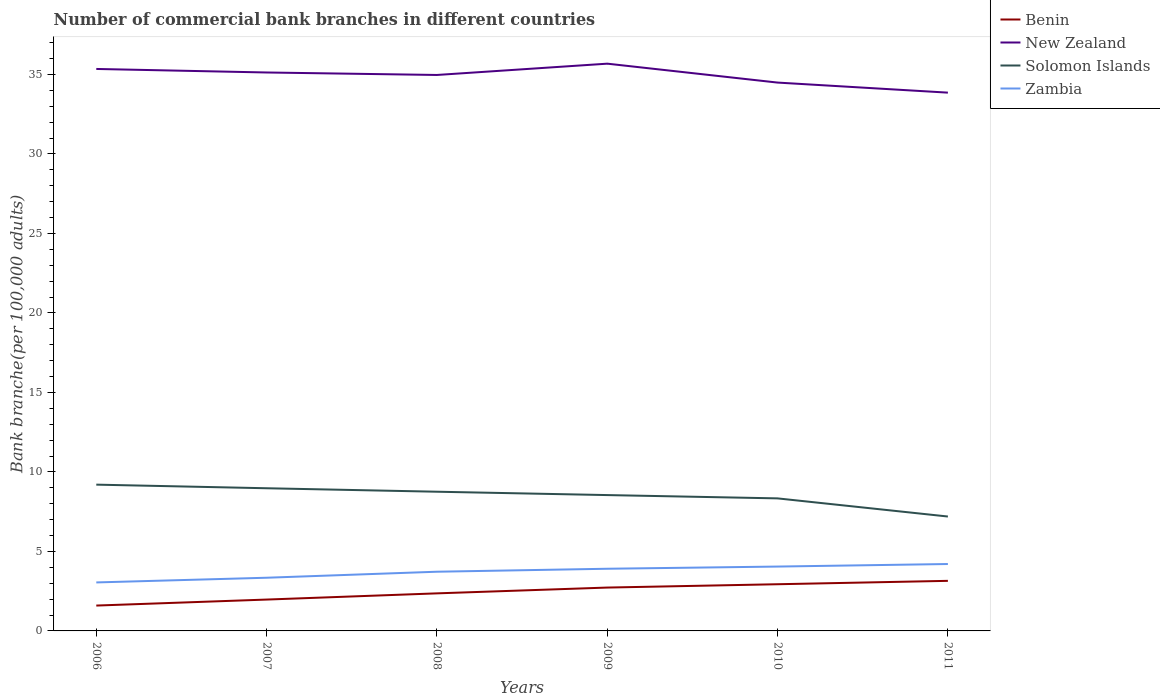Does the line corresponding to Zambia intersect with the line corresponding to New Zealand?
Offer a terse response. No. Across all years, what is the maximum number of commercial bank branches in New Zealand?
Offer a terse response. 33.85. In which year was the number of commercial bank branches in New Zealand maximum?
Keep it short and to the point. 2011. What is the total number of commercial bank branches in Zambia in the graph?
Offer a very short reply. -0.16. What is the difference between the highest and the second highest number of commercial bank branches in Benin?
Keep it short and to the point. 1.55. How many lines are there?
Your answer should be compact. 4. How many years are there in the graph?
Make the answer very short. 6. What is the difference between two consecutive major ticks on the Y-axis?
Provide a short and direct response. 5. Are the values on the major ticks of Y-axis written in scientific E-notation?
Keep it short and to the point. No. Does the graph contain any zero values?
Your answer should be very brief. No. Does the graph contain grids?
Give a very brief answer. No. How many legend labels are there?
Offer a terse response. 4. How are the legend labels stacked?
Provide a succinct answer. Vertical. What is the title of the graph?
Provide a short and direct response. Number of commercial bank branches in different countries. Does "Jamaica" appear as one of the legend labels in the graph?
Offer a very short reply. No. What is the label or title of the Y-axis?
Offer a very short reply. Bank branche(per 100,0 adults). What is the Bank branche(per 100,000 adults) of Benin in 2006?
Give a very brief answer. 1.59. What is the Bank branche(per 100,000 adults) of New Zealand in 2006?
Offer a very short reply. 35.34. What is the Bank branche(per 100,000 adults) in Solomon Islands in 2006?
Ensure brevity in your answer.  9.2. What is the Bank branche(per 100,000 adults) in Zambia in 2006?
Provide a succinct answer. 3.05. What is the Bank branche(per 100,000 adults) of Benin in 2007?
Offer a terse response. 1.97. What is the Bank branche(per 100,000 adults) of New Zealand in 2007?
Your response must be concise. 35.12. What is the Bank branche(per 100,000 adults) in Solomon Islands in 2007?
Make the answer very short. 8.97. What is the Bank branche(per 100,000 adults) of Zambia in 2007?
Provide a succinct answer. 3.34. What is the Bank branche(per 100,000 adults) of Benin in 2008?
Make the answer very short. 2.36. What is the Bank branche(per 100,000 adults) of New Zealand in 2008?
Your answer should be compact. 34.97. What is the Bank branche(per 100,000 adults) in Solomon Islands in 2008?
Keep it short and to the point. 8.75. What is the Bank branche(per 100,000 adults) of Zambia in 2008?
Offer a terse response. 3.72. What is the Bank branche(per 100,000 adults) of Benin in 2009?
Provide a succinct answer. 2.73. What is the Bank branche(per 100,000 adults) in New Zealand in 2009?
Your response must be concise. 35.68. What is the Bank branche(per 100,000 adults) in Solomon Islands in 2009?
Offer a terse response. 8.54. What is the Bank branche(per 100,000 adults) of Zambia in 2009?
Make the answer very short. 3.91. What is the Bank branche(per 100,000 adults) in Benin in 2010?
Offer a terse response. 2.94. What is the Bank branche(per 100,000 adults) of New Zealand in 2010?
Offer a terse response. 34.49. What is the Bank branche(per 100,000 adults) of Solomon Islands in 2010?
Ensure brevity in your answer.  8.34. What is the Bank branche(per 100,000 adults) in Zambia in 2010?
Your answer should be compact. 4.05. What is the Bank branche(per 100,000 adults) of Benin in 2011?
Keep it short and to the point. 3.15. What is the Bank branche(per 100,000 adults) in New Zealand in 2011?
Offer a terse response. 33.85. What is the Bank branche(per 100,000 adults) of Solomon Islands in 2011?
Keep it short and to the point. 7.19. What is the Bank branche(per 100,000 adults) in Zambia in 2011?
Ensure brevity in your answer.  4.21. Across all years, what is the maximum Bank branche(per 100,000 adults) in Benin?
Make the answer very short. 3.15. Across all years, what is the maximum Bank branche(per 100,000 adults) in New Zealand?
Your answer should be compact. 35.68. Across all years, what is the maximum Bank branche(per 100,000 adults) in Solomon Islands?
Offer a very short reply. 9.2. Across all years, what is the maximum Bank branche(per 100,000 adults) of Zambia?
Provide a succinct answer. 4.21. Across all years, what is the minimum Bank branche(per 100,000 adults) in Benin?
Your response must be concise. 1.59. Across all years, what is the minimum Bank branche(per 100,000 adults) of New Zealand?
Provide a short and direct response. 33.85. Across all years, what is the minimum Bank branche(per 100,000 adults) in Solomon Islands?
Provide a succinct answer. 7.19. Across all years, what is the minimum Bank branche(per 100,000 adults) in Zambia?
Offer a very short reply. 3.05. What is the total Bank branche(per 100,000 adults) in Benin in the graph?
Provide a short and direct response. 14.74. What is the total Bank branche(per 100,000 adults) of New Zealand in the graph?
Provide a short and direct response. 209.45. What is the total Bank branche(per 100,000 adults) of Solomon Islands in the graph?
Your answer should be very brief. 51. What is the total Bank branche(per 100,000 adults) of Zambia in the graph?
Ensure brevity in your answer.  22.28. What is the difference between the Bank branche(per 100,000 adults) of Benin in 2006 and that in 2007?
Provide a short and direct response. -0.38. What is the difference between the Bank branche(per 100,000 adults) of New Zealand in 2006 and that in 2007?
Give a very brief answer. 0.22. What is the difference between the Bank branche(per 100,000 adults) of Solomon Islands in 2006 and that in 2007?
Your response must be concise. 0.23. What is the difference between the Bank branche(per 100,000 adults) in Zambia in 2006 and that in 2007?
Your response must be concise. -0.3. What is the difference between the Bank branche(per 100,000 adults) of Benin in 2006 and that in 2008?
Your response must be concise. -0.77. What is the difference between the Bank branche(per 100,000 adults) of New Zealand in 2006 and that in 2008?
Offer a very short reply. 0.38. What is the difference between the Bank branche(per 100,000 adults) in Solomon Islands in 2006 and that in 2008?
Your answer should be very brief. 0.45. What is the difference between the Bank branche(per 100,000 adults) of Zambia in 2006 and that in 2008?
Offer a terse response. -0.67. What is the difference between the Bank branche(per 100,000 adults) of Benin in 2006 and that in 2009?
Your response must be concise. -1.13. What is the difference between the Bank branche(per 100,000 adults) in New Zealand in 2006 and that in 2009?
Provide a short and direct response. -0.33. What is the difference between the Bank branche(per 100,000 adults) in Solomon Islands in 2006 and that in 2009?
Make the answer very short. 0.66. What is the difference between the Bank branche(per 100,000 adults) of Zambia in 2006 and that in 2009?
Give a very brief answer. -0.86. What is the difference between the Bank branche(per 100,000 adults) of Benin in 2006 and that in 2010?
Your answer should be compact. -1.34. What is the difference between the Bank branche(per 100,000 adults) in New Zealand in 2006 and that in 2010?
Your answer should be compact. 0.86. What is the difference between the Bank branche(per 100,000 adults) in Solomon Islands in 2006 and that in 2010?
Provide a succinct answer. 0.86. What is the difference between the Bank branche(per 100,000 adults) of Zambia in 2006 and that in 2010?
Provide a succinct answer. -1. What is the difference between the Bank branche(per 100,000 adults) of Benin in 2006 and that in 2011?
Give a very brief answer. -1.55. What is the difference between the Bank branche(per 100,000 adults) of New Zealand in 2006 and that in 2011?
Offer a very short reply. 1.49. What is the difference between the Bank branche(per 100,000 adults) of Solomon Islands in 2006 and that in 2011?
Provide a succinct answer. 2.01. What is the difference between the Bank branche(per 100,000 adults) of Zambia in 2006 and that in 2011?
Ensure brevity in your answer.  -1.16. What is the difference between the Bank branche(per 100,000 adults) in Benin in 2007 and that in 2008?
Provide a succinct answer. -0.39. What is the difference between the Bank branche(per 100,000 adults) in New Zealand in 2007 and that in 2008?
Offer a very short reply. 0.16. What is the difference between the Bank branche(per 100,000 adults) in Solomon Islands in 2007 and that in 2008?
Your answer should be compact. 0.22. What is the difference between the Bank branche(per 100,000 adults) of Zambia in 2007 and that in 2008?
Your response must be concise. -0.38. What is the difference between the Bank branche(per 100,000 adults) in Benin in 2007 and that in 2009?
Keep it short and to the point. -0.76. What is the difference between the Bank branche(per 100,000 adults) of New Zealand in 2007 and that in 2009?
Keep it short and to the point. -0.55. What is the difference between the Bank branche(per 100,000 adults) in Solomon Islands in 2007 and that in 2009?
Provide a short and direct response. 0.43. What is the difference between the Bank branche(per 100,000 adults) of Zambia in 2007 and that in 2009?
Give a very brief answer. -0.56. What is the difference between the Bank branche(per 100,000 adults) in Benin in 2007 and that in 2010?
Your answer should be compact. -0.96. What is the difference between the Bank branche(per 100,000 adults) in New Zealand in 2007 and that in 2010?
Your answer should be compact. 0.63. What is the difference between the Bank branche(per 100,000 adults) of Solomon Islands in 2007 and that in 2010?
Your answer should be very brief. 0.64. What is the difference between the Bank branche(per 100,000 adults) of Zambia in 2007 and that in 2010?
Make the answer very short. -0.7. What is the difference between the Bank branche(per 100,000 adults) in Benin in 2007 and that in 2011?
Make the answer very short. -1.18. What is the difference between the Bank branche(per 100,000 adults) in New Zealand in 2007 and that in 2011?
Offer a very short reply. 1.27. What is the difference between the Bank branche(per 100,000 adults) in Solomon Islands in 2007 and that in 2011?
Keep it short and to the point. 1.78. What is the difference between the Bank branche(per 100,000 adults) in Zambia in 2007 and that in 2011?
Make the answer very short. -0.86. What is the difference between the Bank branche(per 100,000 adults) in Benin in 2008 and that in 2009?
Provide a short and direct response. -0.36. What is the difference between the Bank branche(per 100,000 adults) of New Zealand in 2008 and that in 2009?
Your answer should be compact. -0.71. What is the difference between the Bank branche(per 100,000 adults) in Solomon Islands in 2008 and that in 2009?
Your response must be concise. 0.21. What is the difference between the Bank branche(per 100,000 adults) of Zambia in 2008 and that in 2009?
Keep it short and to the point. -0.19. What is the difference between the Bank branche(per 100,000 adults) in Benin in 2008 and that in 2010?
Your answer should be compact. -0.57. What is the difference between the Bank branche(per 100,000 adults) in New Zealand in 2008 and that in 2010?
Your answer should be compact. 0.48. What is the difference between the Bank branche(per 100,000 adults) of Solomon Islands in 2008 and that in 2010?
Give a very brief answer. 0.42. What is the difference between the Bank branche(per 100,000 adults) in Zambia in 2008 and that in 2010?
Make the answer very short. -0.32. What is the difference between the Bank branche(per 100,000 adults) of Benin in 2008 and that in 2011?
Provide a succinct answer. -0.79. What is the difference between the Bank branche(per 100,000 adults) of New Zealand in 2008 and that in 2011?
Give a very brief answer. 1.11. What is the difference between the Bank branche(per 100,000 adults) in Solomon Islands in 2008 and that in 2011?
Your answer should be very brief. 1.56. What is the difference between the Bank branche(per 100,000 adults) in Zambia in 2008 and that in 2011?
Your answer should be compact. -0.48. What is the difference between the Bank branche(per 100,000 adults) in Benin in 2009 and that in 2010?
Your answer should be very brief. -0.21. What is the difference between the Bank branche(per 100,000 adults) in New Zealand in 2009 and that in 2010?
Provide a succinct answer. 1.19. What is the difference between the Bank branche(per 100,000 adults) of Solomon Islands in 2009 and that in 2010?
Provide a short and direct response. 0.21. What is the difference between the Bank branche(per 100,000 adults) of Zambia in 2009 and that in 2010?
Offer a very short reply. -0.14. What is the difference between the Bank branche(per 100,000 adults) of Benin in 2009 and that in 2011?
Offer a very short reply. -0.42. What is the difference between the Bank branche(per 100,000 adults) in New Zealand in 2009 and that in 2011?
Keep it short and to the point. 1.82. What is the difference between the Bank branche(per 100,000 adults) of Solomon Islands in 2009 and that in 2011?
Your answer should be compact. 1.35. What is the difference between the Bank branche(per 100,000 adults) in Zambia in 2009 and that in 2011?
Your answer should be compact. -0.3. What is the difference between the Bank branche(per 100,000 adults) of Benin in 2010 and that in 2011?
Your response must be concise. -0.21. What is the difference between the Bank branche(per 100,000 adults) of New Zealand in 2010 and that in 2011?
Provide a succinct answer. 0.63. What is the difference between the Bank branche(per 100,000 adults) of Solomon Islands in 2010 and that in 2011?
Give a very brief answer. 1.14. What is the difference between the Bank branche(per 100,000 adults) of Zambia in 2010 and that in 2011?
Offer a terse response. -0.16. What is the difference between the Bank branche(per 100,000 adults) in Benin in 2006 and the Bank branche(per 100,000 adults) in New Zealand in 2007?
Provide a short and direct response. -33.53. What is the difference between the Bank branche(per 100,000 adults) in Benin in 2006 and the Bank branche(per 100,000 adults) in Solomon Islands in 2007?
Ensure brevity in your answer.  -7.38. What is the difference between the Bank branche(per 100,000 adults) in Benin in 2006 and the Bank branche(per 100,000 adults) in Zambia in 2007?
Provide a succinct answer. -1.75. What is the difference between the Bank branche(per 100,000 adults) of New Zealand in 2006 and the Bank branche(per 100,000 adults) of Solomon Islands in 2007?
Keep it short and to the point. 26.37. What is the difference between the Bank branche(per 100,000 adults) in New Zealand in 2006 and the Bank branche(per 100,000 adults) in Zambia in 2007?
Offer a very short reply. 32. What is the difference between the Bank branche(per 100,000 adults) of Solomon Islands in 2006 and the Bank branche(per 100,000 adults) of Zambia in 2007?
Provide a succinct answer. 5.86. What is the difference between the Bank branche(per 100,000 adults) in Benin in 2006 and the Bank branche(per 100,000 adults) in New Zealand in 2008?
Provide a short and direct response. -33.37. What is the difference between the Bank branche(per 100,000 adults) in Benin in 2006 and the Bank branche(per 100,000 adults) in Solomon Islands in 2008?
Provide a succinct answer. -7.16. What is the difference between the Bank branche(per 100,000 adults) in Benin in 2006 and the Bank branche(per 100,000 adults) in Zambia in 2008?
Your answer should be compact. -2.13. What is the difference between the Bank branche(per 100,000 adults) of New Zealand in 2006 and the Bank branche(per 100,000 adults) of Solomon Islands in 2008?
Give a very brief answer. 26.59. What is the difference between the Bank branche(per 100,000 adults) in New Zealand in 2006 and the Bank branche(per 100,000 adults) in Zambia in 2008?
Ensure brevity in your answer.  31.62. What is the difference between the Bank branche(per 100,000 adults) of Solomon Islands in 2006 and the Bank branche(per 100,000 adults) of Zambia in 2008?
Your answer should be very brief. 5.48. What is the difference between the Bank branche(per 100,000 adults) in Benin in 2006 and the Bank branche(per 100,000 adults) in New Zealand in 2009?
Ensure brevity in your answer.  -34.08. What is the difference between the Bank branche(per 100,000 adults) of Benin in 2006 and the Bank branche(per 100,000 adults) of Solomon Islands in 2009?
Your answer should be very brief. -6.95. What is the difference between the Bank branche(per 100,000 adults) of Benin in 2006 and the Bank branche(per 100,000 adults) of Zambia in 2009?
Your answer should be compact. -2.31. What is the difference between the Bank branche(per 100,000 adults) of New Zealand in 2006 and the Bank branche(per 100,000 adults) of Solomon Islands in 2009?
Ensure brevity in your answer.  26.8. What is the difference between the Bank branche(per 100,000 adults) in New Zealand in 2006 and the Bank branche(per 100,000 adults) in Zambia in 2009?
Make the answer very short. 31.43. What is the difference between the Bank branche(per 100,000 adults) in Solomon Islands in 2006 and the Bank branche(per 100,000 adults) in Zambia in 2009?
Ensure brevity in your answer.  5.29. What is the difference between the Bank branche(per 100,000 adults) of Benin in 2006 and the Bank branche(per 100,000 adults) of New Zealand in 2010?
Provide a succinct answer. -32.89. What is the difference between the Bank branche(per 100,000 adults) of Benin in 2006 and the Bank branche(per 100,000 adults) of Solomon Islands in 2010?
Give a very brief answer. -6.74. What is the difference between the Bank branche(per 100,000 adults) in Benin in 2006 and the Bank branche(per 100,000 adults) in Zambia in 2010?
Make the answer very short. -2.45. What is the difference between the Bank branche(per 100,000 adults) of New Zealand in 2006 and the Bank branche(per 100,000 adults) of Solomon Islands in 2010?
Give a very brief answer. 27.01. What is the difference between the Bank branche(per 100,000 adults) in New Zealand in 2006 and the Bank branche(per 100,000 adults) in Zambia in 2010?
Your answer should be very brief. 31.3. What is the difference between the Bank branche(per 100,000 adults) in Solomon Islands in 2006 and the Bank branche(per 100,000 adults) in Zambia in 2010?
Your answer should be very brief. 5.15. What is the difference between the Bank branche(per 100,000 adults) in Benin in 2006 and the Bank branche(per 100,000 adults) in New Zealand in 2011?
Your answer should be compact. -32.26. What is the difference between the Bank branche(per 100,000 adults) in Benin in 2006 and the Bank branche(per 100,000 adults) in Solomon Islands in 2011?
Offer a very short reply. -5.6. What is the difference between the Bank branche(per 100,000 adults) of Benin in 2006 and the Bank branche(per 100,000 adults) of Zambia in 2011?
Give a very brief answer. -2.61. What is the difference between the Bank branche(per 100,000 adults) in New Zealand in 2006 and the Bank branche(per 100,000 adults) in Solomon Islands in 2011?
Your answer should be compact. 28.15. What is the difference between the Bank branche(per 100,000 adults) of New Zealand in 2006 and the Bank branche(per 100,000 adults) of Zambia in 2011?
Offer a very short reply. 31.14. What is the difference between the Bank branche(per 100,000 adults) of Solomon Islands in 2006 and the Bank branche(per 100,000 adults) of Zambia in 2011?
Give a very brief answer. 4.99. What is the difference between the Bank branche(per 100,000 adults) of Benin in 2007 and the Bank branche(per 100,000 adults) of New Zealand in 2008?
Offer a very short reply. -32.99. What is the difference between the Bank branche(per 100,000 adults) of Benin in 2007 and the Bank branche(per 100,000 adults) of Solomon Islands in 2008?
Ensure brevity in your answer.  -6.78. What is the difference between the Bank branche(per 100,000 adults) in Benin in 2007 and the Bank branche(per 100,000 adults) in Zambia in 2008?
Provide a short and direct response. -1.75. What is the difference between the Bank branche(per 100,000 adults) in New Zealand in 2007 and the Bank branche(per 100,000 adults) in Solomon Islands in 2008?
Give a very brief answer. 26.37. What is the difference between the Bank branche(per 100,000 adults) in New Zealand in 2007 and the Bank branche(per 100,000 adults) in Zambia in 2008?
Make the answer very short. 31.4. What is the difference between the Bank branche(per 100,000 adults) of Solomon Islands in 2007 and the Bank branche(per 100,000 adults) of Zambia in 2008?
Offer a terse response. 5.25. What is the difference between the Bank branche(per 100,000 adults) in Benin in 2007 and the Bank branche(per 100,000 adults) in New Zealand in 2009?
Your answer should be very brief. -33.7. What is the difference between the Bank branche(per 100,000 adults) in Benin in 2007 and the Bank branche(per 100,000 adults) in Solomon Islands in 2009?
Give a very brief answer. -6.57. What is the difference between the Bank branche(per 100,000 adults) of Benin in 2007 and the Bank branche(per 100,000 adults) of Zambia in 2009?
Provide a succinct answer. -1.94. What is the difference between the Bank branche(per 100,000 adults) of New Zealand in 2007 and the Bank branche(per 100,000 adults) of Solomon Islands in 2009?
Your answer should be very brief. 26.58. What is the difference between the Bank branche(per 100,000 adults) of New Zealand in 2007 and the Bank branche(per 100,000 adults) of Zambia in 2009?
Your answer should be very brief. 31.21. What is the difference between the Bank branche(per 100,000 adults) of Solomon Islands in 2007 and the Bank branche(per 100,000 adults) of Zambia in 2009?
Give a very brief answer. 5.06. What is the difference between the Bank branche(per 100,000 adults) in Benin in 2007 and the Bank branche(per 100,000 adults) in New Zealand in 2010?
Your answer should be very brief. -32.52. What is the difference between the Bank branche(per 100,000 adults) of Benin in 2007 and the Bank branche(per 100,000 adults) of Solomon Islands in 2010?
Provide a short and direct response. -6.36. What is the difference between the Bank branche(per 100,000 adults) in Benin in 2007 and the Bank branche(per 100,000 adults) in Zambia in 2010?
Your answer should be compact. -2.08. What is the difference between the Bank branche(per 100,000 adults) of New Zealand in 2007 and the Bank branche(per 100,000 adults) of Solomon Islands in 2010?
Keep it short and to the point. 26.79. What is the difference between the Bank branche(per 100,000 adults) in New Zealand in 2007 and the Bank branche(per 100,000 adults) in Zambia in 2010?
Ensure brevity in your answer.  31.07. What is the difference between the Bank branche(per 100,000 adults) in Solomon Islands in 2007 and the Bank branche(per 100,000 adults) in Zambia in 2010?
Provide a succinct answer. 4.93. What is the difference between the Bank branche(per 100,000 adults) in Benin in 2007 and the Bank branche(per 100,000 adults) in New Zealand in 2011?
Provide a succinct answer. -31.88. What is the difference between the Bank branche(per 100,000 adults) of Benin in 2007 and the Bank branche(per 100,000 adults) of Solomon Islands in 2011?
Your response must be concise. -5.22. What is the difference between the Bank branche(per 100,000 adults) in Benin in 2007 and the Bank branche(per 100,000 adults) in Zambia in 2011?
Give a very brief answer. -2.24. What is the difference between the Bank branche(per 100,000 adults) in New Zealand in 2007 and the Bank branche(per 100,000 adults) in Solomon Islands in 2011?
Provide a short and direct response. 27.93. What is the difference between the Bank branche(per 100,000 adults) of New Zealand in 2007 and the Bank branche(per 100,000 adults) of Zambia in 2011?
Ensure brevity in your answer.  30.91. What is the difference between the Bank branche(per 100,000 adults) in Solomon Islands in 2007 and the Bank branche(per 100,000 adults) in Zambia in 2011?
Keep it short and to the point. 4.76. What is the difference between the Bank branche(per 100,000 adults) in Benin in 2008 and the Bank branche(per 100,000 adults) in New Zealand in 2009?
Keep it short and to the point. -33.31. What is the difference between the Bank branche(per 100,000 adults) in Benin in 2008 and the Bank branche(per 100,000 adults) in Solomon Islands in 2009?
Provide a short and direct response. -6.18. What is the difference between the Bank branche(per 100,000 adults) of Benin in 2008 and the Bank branche(per 100,000 adults) of Zambia in 2009?
Offer a terse response. -1.55. What is the difference between the Bank branche(per 100,000 adults) of New Zealand in 2008 and the Bank branche(per 100,000 adults) of Solomon Islands in 2009?
Keep it short and to the point. 26.42. What is the difference between the Bank branche(per 100,000 adults) of New Zealand in 2008 and the Bank branche(per 100,000 adults) of Zambia in 2009?
Your answer should be compact. 31.06. What is the difference between the Bank branche(per 100,000 adults) in Solomon Islands in 2008 and the Bank branche(per 100,000 adults) in Zambia in 2009?
Provide a succinct answer. 4.85. What is the difference between the Bank branche(per 100,000 adults) in Benin in 2008 and the Bank branche(per 100,000 adults) in New Zealand in 2010?
Offer a very short reply. -32.12. What is the difference between the Bank branche(per 100,000 adults) in Benin in 2008 and the Bank branche(per 100,000 adults) in Solomon Islands in 2010?
Offer a very short reply. -5.97. What is the difference between the Bank branche(per 100,000 adults) in Benin in 2008 and the Bank branche(per 100,000 adults) in Zambia in 2010?
Ensure brevity in your answer.  -1.68. What is the difference between the Bank branche(per 100,000 adults) in New Zealand in 2008 and the Bank branche(per 100,000 adults) in Solomon Islands in 2010?
Make the answer very short. 26.63. What is the difference between the Bank branche(per 100,000 adults) of New Zealand in 2008 and the Bank branche(per 100,000 adults) of Zambia in 2010?
Keep it short and to the point. 30.92. What is the difference between the Bank branche(per 100,000 adults) in Solomon Islands in 2008 and the Bank branche(per 100,000 adults) in Zambia in 2010?
Offer a terse response. 4.71. What is the difference between the Bank branche(per 100,000 adults) in Benin in 2008 and the Bank branche(per 100,000 adults) in New Zealand in 2011?
Ensure brevity in your answer.  -31.49. What is the difference between the Bank branche(per 100,000 adults) in Benin in 2008 and the Bank branche(per 100,000 adults) in Solomon Islands in 2011?
Provide a short and direct response. -4.83. What is the difference between the Bank branche(per 100,000 adults) in Benin in 2008 and the Bank branche(per 100,000 adults) in Zambia in 2011?
Provide a short and direct response. -1.85. What is the difference between the Bank branche(per 100,000 adults) of New Zealand in 2008 and the Bank branche(per 100,000 adults) of Solomon Islands in 2011?
Offer a terse response. 27.77. What is the difference between the Bank branche(per 100,000 adults) in New Zealand in 2008 and the Bank branche(per 100,000 adults) in Zambia in 2011?
Your response must be concise. 30.76. What is the difference between the Bank branche(per 100,000 adults) in Solomon Islands in 2008 and the Bank branche(per 100,000 adults) in Zambia in 2011?
Provide a short and direct response. 4.55. What is the difference between the Bank branche(per 100,000 adults) in Benin in 2009 and the Bank branche(per 100,000 adults) in New Zealand in 2010?
Give a very brief answer. -31.76. What is the difference between the Bank branche(per 100,000 adults) of Benin in 2009 and the Bank branche(per 100,000 adults) of Solomon Islands in 2010?
Ensure brevity in your answer.  -5.61. What is the difference between the Bank branche(per 100,000 adults) in Benin in 2009 and the Bank branche(per 100,000 adults) in Zambia in 2010?
Your answer should be compact. -1.32. What is the difference between the Bank branche(per 100,000 adults) in New Zealand in 2009 and the Bank branche(per 100,000 adults) in Solomon Islands in 2010?
Make the answer very short. 27.34. What is the difference between the Bank branche(per 100,000 adults) of New Zealand in 2009 and the Bank branche(per 100,000 adults) of Zambia in 2010?
Provide a short and direct response. 31.63. What is the difference between the Bank branche(per 100,000 adults) in Solomon Islands in 2009 and the Bank branche(per 100,000 adults) in Zambia in 2010?
Offer a very short reply. 4.5. What is the difference between the Bank branche(per 100,000 adults) in Benin in 2009 and the Bank branche(per 100,000 adults) in New Zealand in 2011?
Make the answer very short. -31.13. What is the difference between the Bank branche(per 100,000 adults) of Benin in 2009 and the Bank branche(per 100,000 adults) of Solomon Islands in 2011?
Offer a very short reply. -4.47. What is the difference between the Bank branche(per 100,000 adults) in Benin in 2009 and the Bank branche(per 100,000 adults) in Zambia in 2011?
Your response must be concise. -1.48. What is the difference between the Bank branche(per 100,000 adults) in New Zealand in 2009 and the Bank branche(per 100,000 adults) in Solomon Islands in 2011?
Offer a very short reply. 28.48. What is the difference between the Bank branche(per 100,000 adults) in New Zealand in 2009 and the Bank branche(per 100,000 adults) in Zambia in 2011?
Your answer should be very brief. 31.47. What is the difference between the Bank branche(per 100,000 adults) in Solomon Islands in 2009 and the Bank branche(per 100,000 adults) in Zambia in 2011?
Provide a succinct answer. 4.34. What is the difference between the Bank branche(per 100,000 adults) of Benin in 2010 and the Bank branche(per 100,000 adults) of New Zealand in 2011?
Provide a succinct answer. -30.92. What is the difference between the Bank branche(per 100,000 adults) in Benin in 2010 and the Bank branche(per 100,000 adults) in Solomon Islands in 2011?
Ensure brevity in your answer.  -4.26. What is the difference between the Bank branche(per 100,000 adults) in Benin in 2010 and the Bank branche(per 100,000 adults) in Zambia in 2011?
Offer a very short reply. -1.27. What is the difference between the Bank branche(per 100,000 adults) in New Zealand in 2010 and the Bank branche(per 100,000 adults) in Solomon Islands in 2011?
Provide a short and direct response. 27.29. What is the difference between the Bank branche(per 100,000 adults) in New Zealand in 2010 and the Bank branche(per 100,000 adults) in Zambia in 2011?
Provide a succinct answer. 30.28. What is the difference between the Bank branche(per 100,000 adults) of Solomon Islands in 2010 and the Bank branche(per 100,000 adults) of Zambia in 2011?
Offer a very short reply. 4.13. What is the average Bank branche(per 100,000 adults) of Benin per year?
Keep it short and to the point. 2.46. What is the average Bank branche(per 100,000 adults) of New Zealand per year?
Provide a short and direct response. 34.91. What is the average Bank branche(per 100,000 adults) of Solomon Islands per year?
Ensure brevity in your answer.  8.5. What is the average Bank branche(per 100,000 adults) in Zambia per year?
Offer a very short reply. 3.71. In the year 2006, what is the difference between the Bank branche(per 100,000 adults) of Benin and Bank branche(per 100,000 adults) of New Zealand?
Offer a terse response. -33.75. In the year 2006, what is the difference between the Bank branche(per 100,000 adults) in Benin and Bank branche(per 100,000 adults) in Solomon Islands?
Ensure brevity in your answer.  -7.61. In the year 2006, what is the difference between the Bank branche(per 100,000 adults) of Benin and Bank branche(per 100,000 adults) of Zambia?
Give a very brief answer. -1.45. In the year 2006, what is the difference between the Bank branche(per 100,000 adults) in New Zealand and Bank branche(per 100,000 adults) in Solomon Islands?
Offer a terse response. 26.14. In the year 2006, what is the difference between the Bank branche(per 100,000 adults) of New Zealand and Bank branche(per 100,000 adults) of Zambia?
Offer a terse response. 32.29. In the year 2006, what is the difference between the Bank branche(per 100,000 adults) of Solomon Islands and Bank branche(per 100,000 adults) of Zambia?
Ensure brevity in your answer.  6.15. In the year 2007, what is the difference between the Bank branche(per 100,000 adults) of Benin and Bank branche(per 100,000 adults) of New Zealand?
Provide a short and direct response. -33.15. In the year 2007, what is the difference between the Bank branche(per 100,000 adults) of Benin and Bank branche(per 100,000 adults) of Solomon Islands?
Offer a very short reply. -7. In the year 2007, what is the difference between the Bank branche(per 100,000 adults) in Benin and Bank branche(per 100,000 adults) in Zambia?
Offer a terse response. -1.37. In the year 2007, what is the difference between the Bank branche(per 100,000 adults) of New Zealand and Bank branche(per 100,000 adults) of Solomon Islands?
Make the answer very short. 26.15. In the year 2007, what is the difference between the Bank branche(per 100,000 adults) in New Zealand and Bank branche(per 100,000 adults) in Zambia?
Your answer should be compact. 31.78. In the year 2007, what is the difference between the Bank branche(per 100,000 adults) in Solomon Islands and Bank branche(per 100,000 adults) in Zambia?
Keep it short and to the point. 5.63. In the year 2008, what is the difference between the Bank branche(per 100,000 adults) of Benin and Bank branche(per 100,000 adults) of New Zealand?
Your answer should be compact. -32.6. In the year 2008, what is the difference between the Bank branche(per 100,000 adults) in Benin and Bank branche(per 100,000 adults) in Solomon Islands?
Provide a short and direct response. -6.39. In the year 2008, what is the difference between the Bank branche(per 100,000 adults) in Benin and Bank branche(per 100,000 adults) in Zambia?
Offer a very short reply. -1.36. In the year 2008, what is the difference between the Bank branche(per 100,000 adults) of New Zealand and Bank branche(per 100,000 adults) of Solomon Islands?
Offer a terse response. 26.21. In the year 2008, what is the difference between the Bank branche(per 100,000 adults) in New Zealand and Bank branche(per 100,000 adults) in Zambia?
Offer a very short reply. 31.24. In the year 2008, what is the difference between the Bank branche(per 100,000 adults) of Solomon Islands and Bank branche(per 100,000 adults) of Zambia?
Provide a succinct answer. 5.03. In the year 2009, what is the difference between the Bank branche(per 100,000 adults) in Benin and Bank branche(per 100,000 adults) in New Zealand?
Keep it short and to the point. -32.95. In the year 2009, what is the difference between the Bank branche(per 100,000 adults) of Benin and Bank branche(per 100,000 adults) of Solomon Islands?
Your answer should be very brief. -5.82. In the year 2009, what is the difference between the Bank branche(per 100,000 adults) in Benin and Bank branche(per 100,000 adults) in Zambia?
Offer a terse response. -1.18. In the year 2009, what is the difference between the Bank branche(per 100,000 adults) of New Zealand and Bank branche(per 100,000 adults) of Solomon Islands?
Offer a terse response. 27.13. In the year 2009, what is the difference between the Bank branche(per 100,000 adults) of New Zealand and Bank branche(per 100,000 adults) of Zambia?
Your answer should be very brief. 31.77. In the year 2009, what is the difference between the Bank branche(per 100,000 adults) in Solomon Islands and Bank branche(per 100,000 adults) in Zambia?
Your response must be concise. 4.63. In the year 2010, what is the difference between the Bank branche(per 100,000 adults) of Benin and Bank branche(per 100,000 adults) of New Zealand?
Your answer should be compact. -31.55. In the year 2010, what is the difference between the Bank branche(per 100,000 adults) in Benin and Bank branche(per 100,000 adults) in Solomon Islands?
Ensure brevity in your answer.  -5.4. In the year 2010, what is the difference between the Bank branche(per 100,000 adults) of Benin and Bank branche(per 100,000 adults) of Zambia?
Give a very brief answer. -1.11. In the year 2010, what is the difference between the Bank branche(per 100,000 adults) in New Zealand and Bank branche(per 100,000 adults) in Solomon Islands?
Give a very brief answer. 26.15. In the year 2010, what is the difference between the Bank branche(per 100,000 adults) in New Zealand and Bank branche(per 100,000 adults) in Zambia?
Your response must be concise. 30.44. In the year 2010, what is the difference between the Bank branche(per 100,000 adults) in Solomon Islands and Bank branche(per 100,000 adults) in Zambia?
Your response must be concise. 4.29. In the year 2011, what is the difference between the Bank branche(per 100,000 adults) in Benin and Bank branche(per 100,000 adults) in New Zealand?
Your answer should be very brief. -30.7. In the year 2011, what is the difference between the Bank branche(per 100,000 adults) in Benin and Bank branche(per 100,000 adults) in Solomon Islands?
Offer a terse response. -4.04. In the year 2011, what is the difference between the Bank branche(per 100,000 adults) of Benin and Bank branche(per 100,000 adults) of Zambia?
Ensure brevity in your answer.  -1.06. In the year 2011, what is the difference between the Bank branche(per 100,000 adults) in New Zealand and Bank branche(per 100,000 adults) in Solomon Islands?
Offer a terse response. 26.66. In the year 2011, what is the difference between the Bank branche(per 100,000 adults) in New Zealand and Bank branche(per 100,000 adults) in Zambia?
Give a very brief answer. 29.65. In the year 2011, what is the difference between the Bank branche(per 100,000 adults) of Solomon Islands and Bank branche(per 100,000 adults) of Zambia?
Offer a very short reply. 2.99. What is the ratio of the Bank branche(per 100,000 adults) in Benin in 2006 to that in 2007?
Make the answer very short. 0.81. What is the ratio of the Bank branche(per 100,000 adults) of New Zealand in 2006 to that in 2007?
Make the answer very short. 1.01. What is the ratio of the Bank branche(per 100,000 adults) of Solomon Islands in 2006 to that in 2007?
Your answer should be very brief. 1.03. What is the ratio of the Bank branche(per 100,000 adults) in Zambia in 2006 to that in 2007?
Your answer should be very brief. 0.91. What is the ratio of the Bank branche(per 100,000 adults) of Benin in 2006 to that in 2008?
Ensure brevity in your answer.  0.68. What is the ratio of the Bank branche(per 100,000 adults) in New Zealand in 2006 to that in 2008?
Give a very brief answer. 1.01. What is the ratio of the Bank branche(per 100,000 adults) of Solomon Islands in 2006 to that in 2008?
Provide a succinct answer. 1.05. What is the ratio of the Bank branche(per 100,000 adults) of Zambia in 2006 to that in 2008?
Provide a succinct answer. 0.82. What is the ratio of the Bank branche(per 100,000 adults) of Benin in 2006 to that in 2009?
Offer a very short reply. 0.58. What is the ratio of the Bank branche(per 100,000 adults) of Zambia in 2006 to that in 2009?
Your answer should be compact. 0.78. What is the ratio of the Bank branche(per 100,000 adults) of Benin in 2006 to that in 2010?
Ensure brevity in your answer.  0.54. What is the ratio of the Bank branche(per 100,000 adults) of New Zealand in 2006 to that in 2010?
Keep it short and to the point. 1.02. What is the ratio of the Bank branche(per 100,000 adults) in Solomon Islands in 2006 to that in 2010?
Keep it short and to the point. 1.1. What is the ratio of the Bank branche(per 100,000 adults) in Zambia in 2006 to that in 2010?
Your answer should be compact. 0.75. What is the ratio of the Bank branche(per 100,000 adults) of Benin in 2006 to that in 2011?
Your answer should be compact. 0.51. What is the ratio of the Bank branche(per 100,000 adults) in New Zealand in 2006 to that in 2011?
Offer a terse response. 1.04. What is the ratio of the Bank branche(per 100,000 adults) of Solomon Islands in 2006 to that in 2011?
Ensure brevity in your answer.  1.28. What is the ratio of the Bank branche(per 100,000 adults) in Zambia in 2006 to that in 2011?
Make the answer very short. 0.72. What is the ratio of the Bank branche(per 100,000 adults) of Benin in 2007 to that in 2008?
Your answer should be very brief. 0.83. What is the ratio of the Bank branche(per 100,000 adults) of Solomon Islands in 2007 to that in 2008?
Your answer should be very brief. 1.02. What is the ratio of the Bank branche(per 100,000 adults) in Zambia in 2007 to that in 2008?
Keep it short and to the point. 0.9. What is the ratio of the Bank branche(per 100,000 adults) of Benin in 2007 to that in 2009?
Give a very brief answer. 0.72. What is the ratio of the Bank branche(per 100,000 adults) in New Zealand in 2007 to that in 2009?
Keep it short and to the point. 0.98. What is the ratio of the Bank branche(per 100,000 adults) of Solomon Islands in 2007 to that in 2009?
Keep it short and to the point. 1.05. What is the ratio of the Bank branche(per 100,000 adults) of Zambia in 2007 to that in 2009?
Offer a terse response. 0.86. What is the ratio of the Bank branche(per 100,000 adults) in Benin in 2007 to that in 2010?
Provide a succinct answer. 0.67. What is the ratio of the Bank branche(per 100,000 adults) of New Zealand in 2007 to that in 2010?
Give a very brief answer. 1.02. What is the ratio of the Bank branche(per 100,000 adults) in Solomon Islands in 2007 to that in 2010?
Give a very brief answer. 1.08. What is the ratio of the Bank branche(per 100,000 adults) in Zambia in 2007 to that in 2010?
Make the answer very short. 0.83. What is the ratio of the Bank branche(per 100,000 adults) of Benin in 2007 to that in 2011?
Your answer should be very brief. 0.63. What is the ratio of the Bank branche(per 100,000 adults) in New Zealand in 2007 to that in 2011?
Keep it short and to the point. 1.04. What is the ratio of the Bank branche(per 100,000 adults) of Solomon Islands in 2007 to that in 2011?
Make the answer very short. 1.25. What is the ratio of the Bank branche(per 100,000 adults) in Zambia in 2007 to that in 2011?
Offer a very short reply. 0.79. What is the ratio of the Bank branche(per 100,000 adults) of Benin in 2008 to that in 2009?
Your answer should be very brief. 0.87. What is the ratio of the Bank branche(per 100,000 adults) of New Zealand in 2008 to that in 2009?
Make the answer very short. 0.98. What is the ratio of the Bank branche(per 100,000 adults) in Solomon Islands in 2008 to that in 2009?
Provide a short and direct response. 1.02. What is the ratio of the Bank branche(per 100,000 adults) of Zambia in 2008 to that in 2009?
Your answer should be compact. 0.95. What is the ratio of the Bank branche(per 100,000 adults) in Benin in 2008 to that in 2010?
Give a very brief answer. 0.8. What is the ratio of the Bank branche(per 100,000 adults) of New Zealand in 2008 to that in 2010?
Your answer should be very brief. 1.01. What is the ratio of the Bank branche(per 100,000 adults) in Solomon Islands in 2008 to that in 2010?
Keep it short and to the point. 1.05. What is the ratio of the Bank branche(per 100,000 adults) in Zambia in 2008 to that in 2010?
Ensure brevity in your answer.  0.92. What is the ratio of the Bank branche(per 100,000 adults) in Benin in 2008 to that in 2011?
Give a very brief answer. 0.75. What is the ratio of the Bank branche(per 100,000 adults) of New Zealand in 2008 to that in 2011?
Provide a succinct answer. 1.03. What is the ratio of the Bank branche(per 100,000 adults) of Solomon Islands in 2008 to that in 2011?
Make the answer very short. 1.22. What is the ratio of the Bank branche(per 100,000 adults) in Zambia in 2008 to that in 2011?
Offer a very short reply. 0.88. What is the ratio of the Bank branche(per 100,000 adults) in New Zealand in 2009 to that in 2010?
Offer a terse response. 1.03. What is the ratio of the Bank branche(per 100,000 adults) in Solomon Islands in 2009 to that in 2010?
Your answer should be compact. 1.02. What is the ratio of the Bank branche(per 100,000 adults) in Benin in 2009 to that in 2011?
Make the answer very short. 0.87. What is the ratio of the Bank branche(per 100,000 adults) of New Zealand in 2009 to that in 2011?
Provide a short and direct response. 1.05. What is the ratio of the Bank branche(per 100,000 adults) in Solomon Islands in 2009 to that in 2011?
Offer a very short reply. 1.19. What is the ratio of the Bank branche(per 100,000 adults) of Zambia in 2009 to that in 2011?
Provide a short and direct response. 0.93. What is the ratio of the Bank branche(per 100,000 adults) of Benin in 2010 to that in 2011?
Provide a succinct answer. 0.93. What is the ratio of the Bank branche(per 100,000 adults) of New Zealand in 2010 to that in 2011?
Offer a terse response. 1.02. What is the ratio of the Bank branche(per 100,000 adults) of Solomon Islands in 2010 to that in 2011?
Provide a short and direct response. 1.16. What is the ratio of the Bank branche(per 100,000 adults) in Zambia in 2010 to that in 2011?
Make the answer very short. 0.96. What is the difference between the highest and the second highest Bank branche(per 100,000 adults) of Benin?
Your answer should be very brief. 0.21. What is the difference between the highest and the second highest Bank branche(per 100,000 adults) of New Zealand?
Keep it short and to the point. 0.33. What is the difference between the highest and the second highest Bank branche(per 100,000 adults) in Solomon Islands?
Make the answer very short. 0.23. What is the difference between the highest and the second highest Bank branche(per 100,000 adults) in Zambia?
Provide a succinct answer. 0.16. What is the difference between the highest and the lowest Bank branche(per 100,000 adults) in Benin?
Give a very brief answer. 1.55. What is the difference between the highest and the lowest Bank branche(per 100,000 adults) in New Zealand?
Provide a succinct answer. 1.82. What is the difference between the highest and the lowest Bank branche(per 100,000 adults) of Solomon Islands?
Make the answer very short. 2.01. What is the difference between the highest and the lowest Bank branche(per 100,000 adults) in Zambia?
Your answer should be compact. 1.16. 